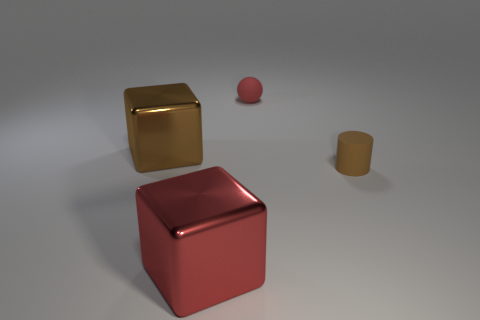Add 2 red cubes. How many objects exist? 6 Subtract all balls. How many objects are left? 3 Subtract 0 gray cylinders. How many objects are left? 4 Subtract all small red rubber blocks. Subtract all large red metal blocks. How many objects are left? 3 Add 4 small brown rubber objects. How many small brown rubber objects are left? 5 Add 3 brown objects. How many brown objects exist? 5 